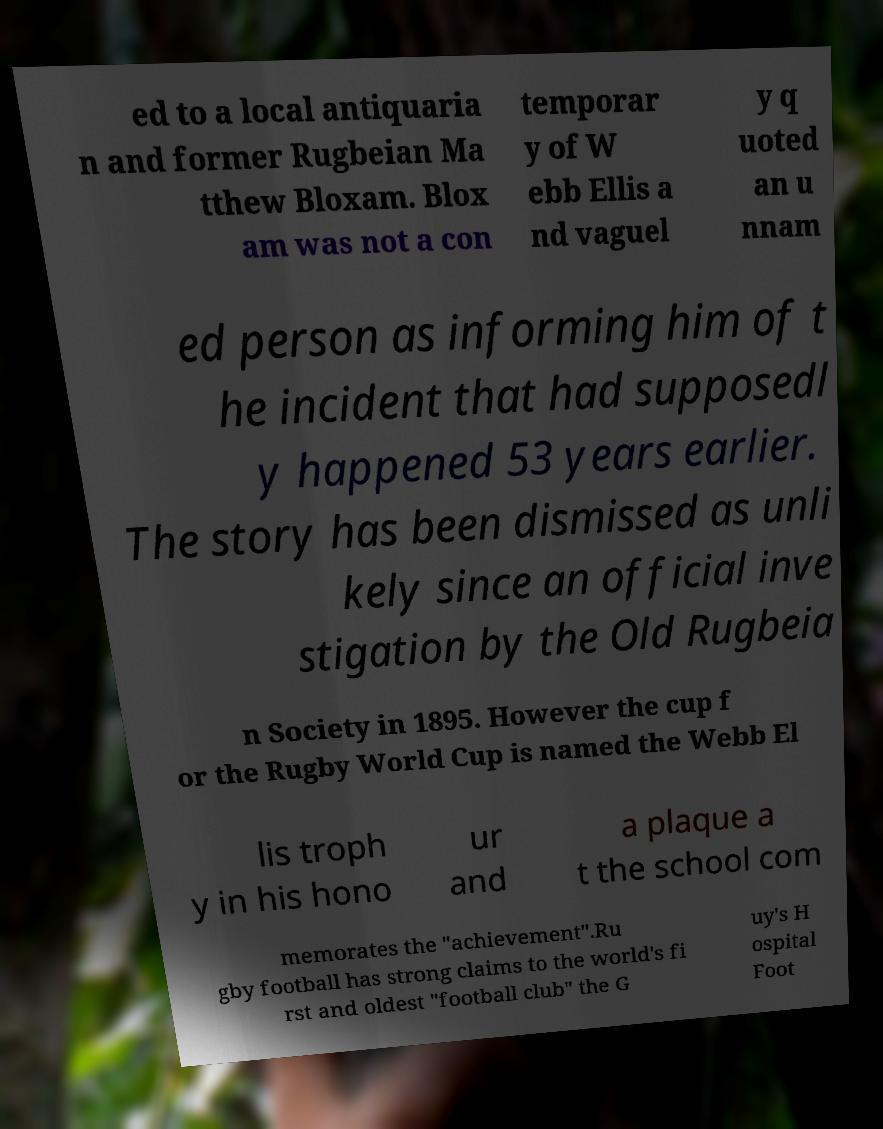Please identify and transcribe the text found in this image. ed to a local antiquaria n and former Rugbeian Ma tthew Bloxam. Blox am was not a con temporar y of W ebb Ellis a nd vaguel y q uoted an u nnam ed person as informing him of t he incident that had supposedl y happened 53 years earlier. The story has been dismissed as unli kely since an official inve stigation by the Old Rugbeia n Society in 1895. However the cup f or the Rugby World Cup is named the Webb El lis troph y in his hono ur and a plaque a t the school com memorates the "achievement".Ru gby football has strong claims to the world's fi rst and oldest "football club" the G uy's H ospital Foot 